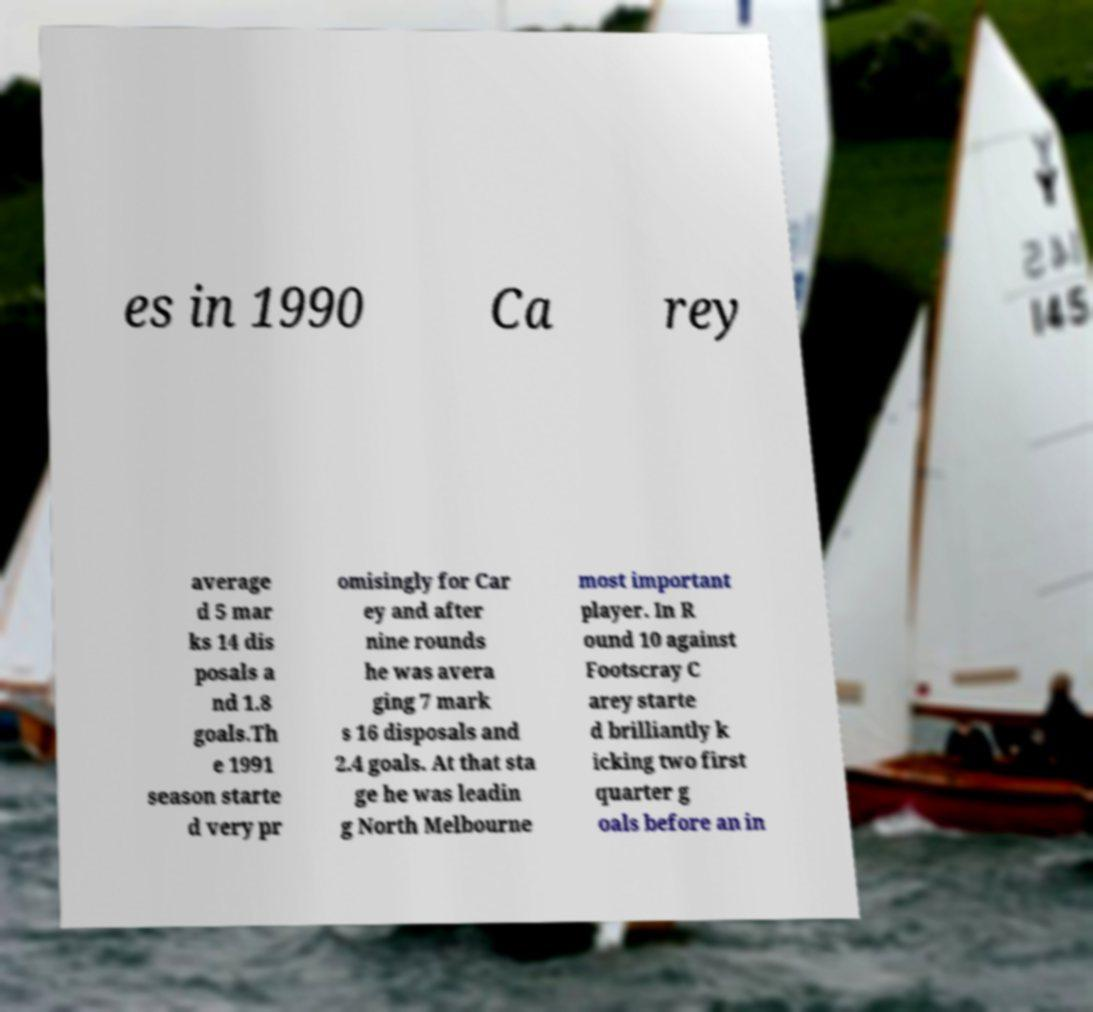There's text embedded in this image that I need extracted. Can you transcribe it verbatim? es in 1990 Ca rey average d 5 mar ks 14 dis posals a nd 1.8 goals.Th e 1991 season starte d very pr omisingly for Car ey and after nine rounds he was avera ging 7 mark s 16 disposals and 2.4 goals. At that sta ge he was leadin g North Melbourne most important player. In R ound 10 against Footscray C arey starte d brilliantly k icking two first quarter g oals before an in 